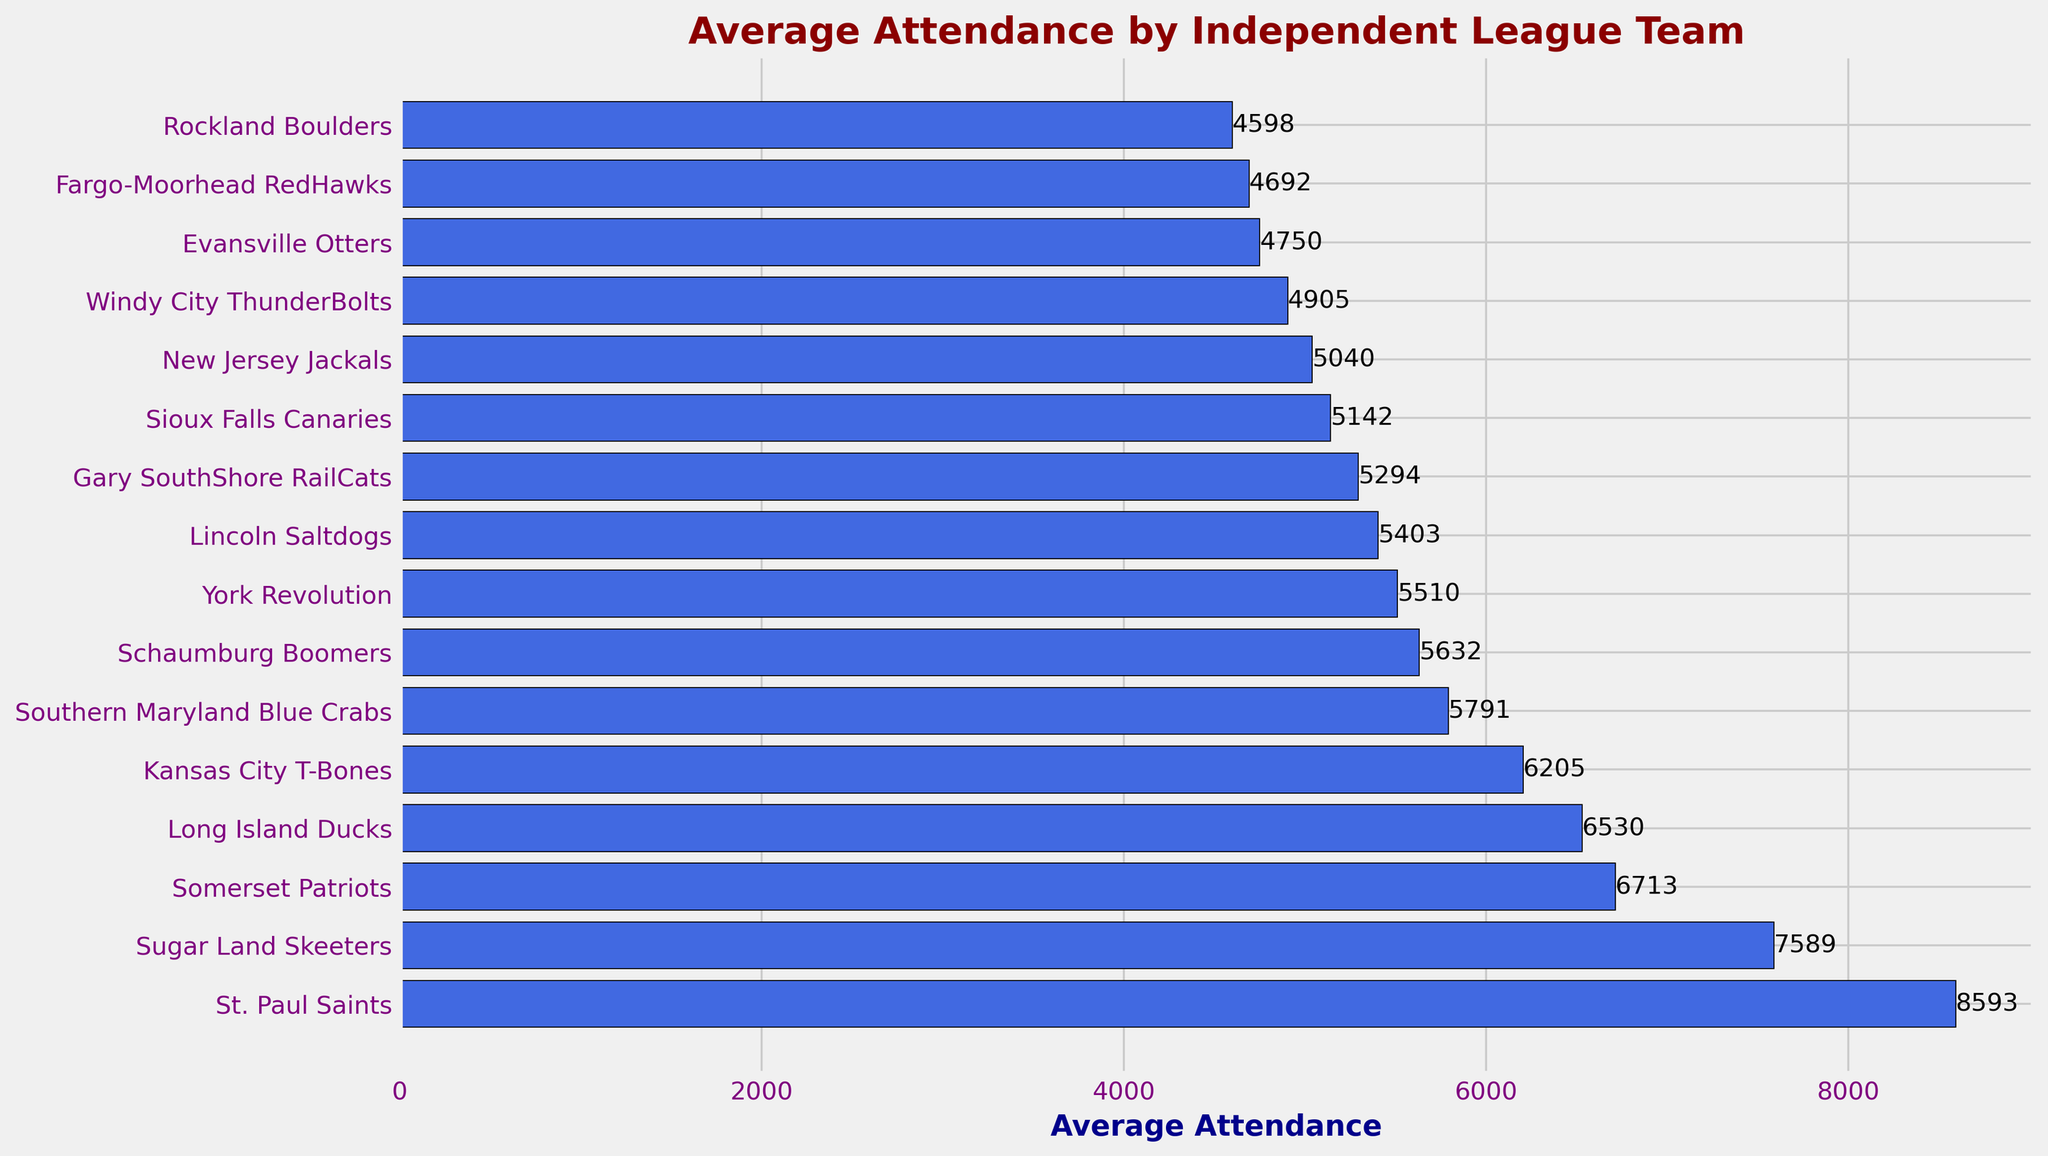Which team has the highest average attendance? The top bar in the plot represents the highest average attendance. By looking at the figure, the St. Paul Saints are at the top with 8,593 average attendees.
Answer: St. Paul Saints What is the difference in average attendance between the team with the highest and the team with the lowest average attendance? To find the difference, subtract the average attendance of the team with the lowest attendance (Rockland Boulders, 4598) from the team with the highest attendance (St. Paul Saints, 8593). So, 8593 - 4598 = 3995.
Answer: 3995 Which teams have an average attendance greater than 6000? By inspecting the bar lengths on the plot, the teams with bars extending beyond the 6000 mark are St. Paul Saints, Sugar Land Skeeters, Somerset Patriots, Long Island Ducks, and Kansas City T-Bones.
Answer: St. Paul Saints, Sugar Land Skeeters, Somerset Patriots, Long Island Ducks, Kansas City T-Bones Is the average attendance of the Sugar Land Skeeters more than 1000 attendees higher than the Southern Maryland Blue Crabs? Compare the average attendance of the two teams. Sugar Land Skeeters have 7,589, and Southern Maryland Blue Crabs have 5,791. Subtract Southern Maryland’s attendance from Sugar Land’s: 7589 - 5791 = 1798, which is indeed more than 1000.
Answer: Yes How many teams have an average attendance between 5000 and 6000? Observe the bar lengths and count the bars that lie between the 5000 and 6000 ticks on the x-axis. These teams are Southern Maryland Blue Crabs, Schaumburg Boomers, York Revolution, Lincoln Saltdogs, Gary SouthShore RailCats, and Sioux Falls Canaries.
Answer: 6 What is the combined average attendance of the teams with the three lowest average attendances? Identify the three teams with the smallest bars: Rockland Boulders (4598), Fargo-Moorhead RedHawks (4692), and Evansville Otters (4750). Sum their attendances: 4598 + 4692 + 4750 = 14040.
Answer: 14040 Which team is placed fifth in terms of average attendance? Count the bars from the top to the fifth one. The fifth bar represents the Kansas City T-Bones with an average attendance of 6205.
Answer: Kansas City T-Bones 